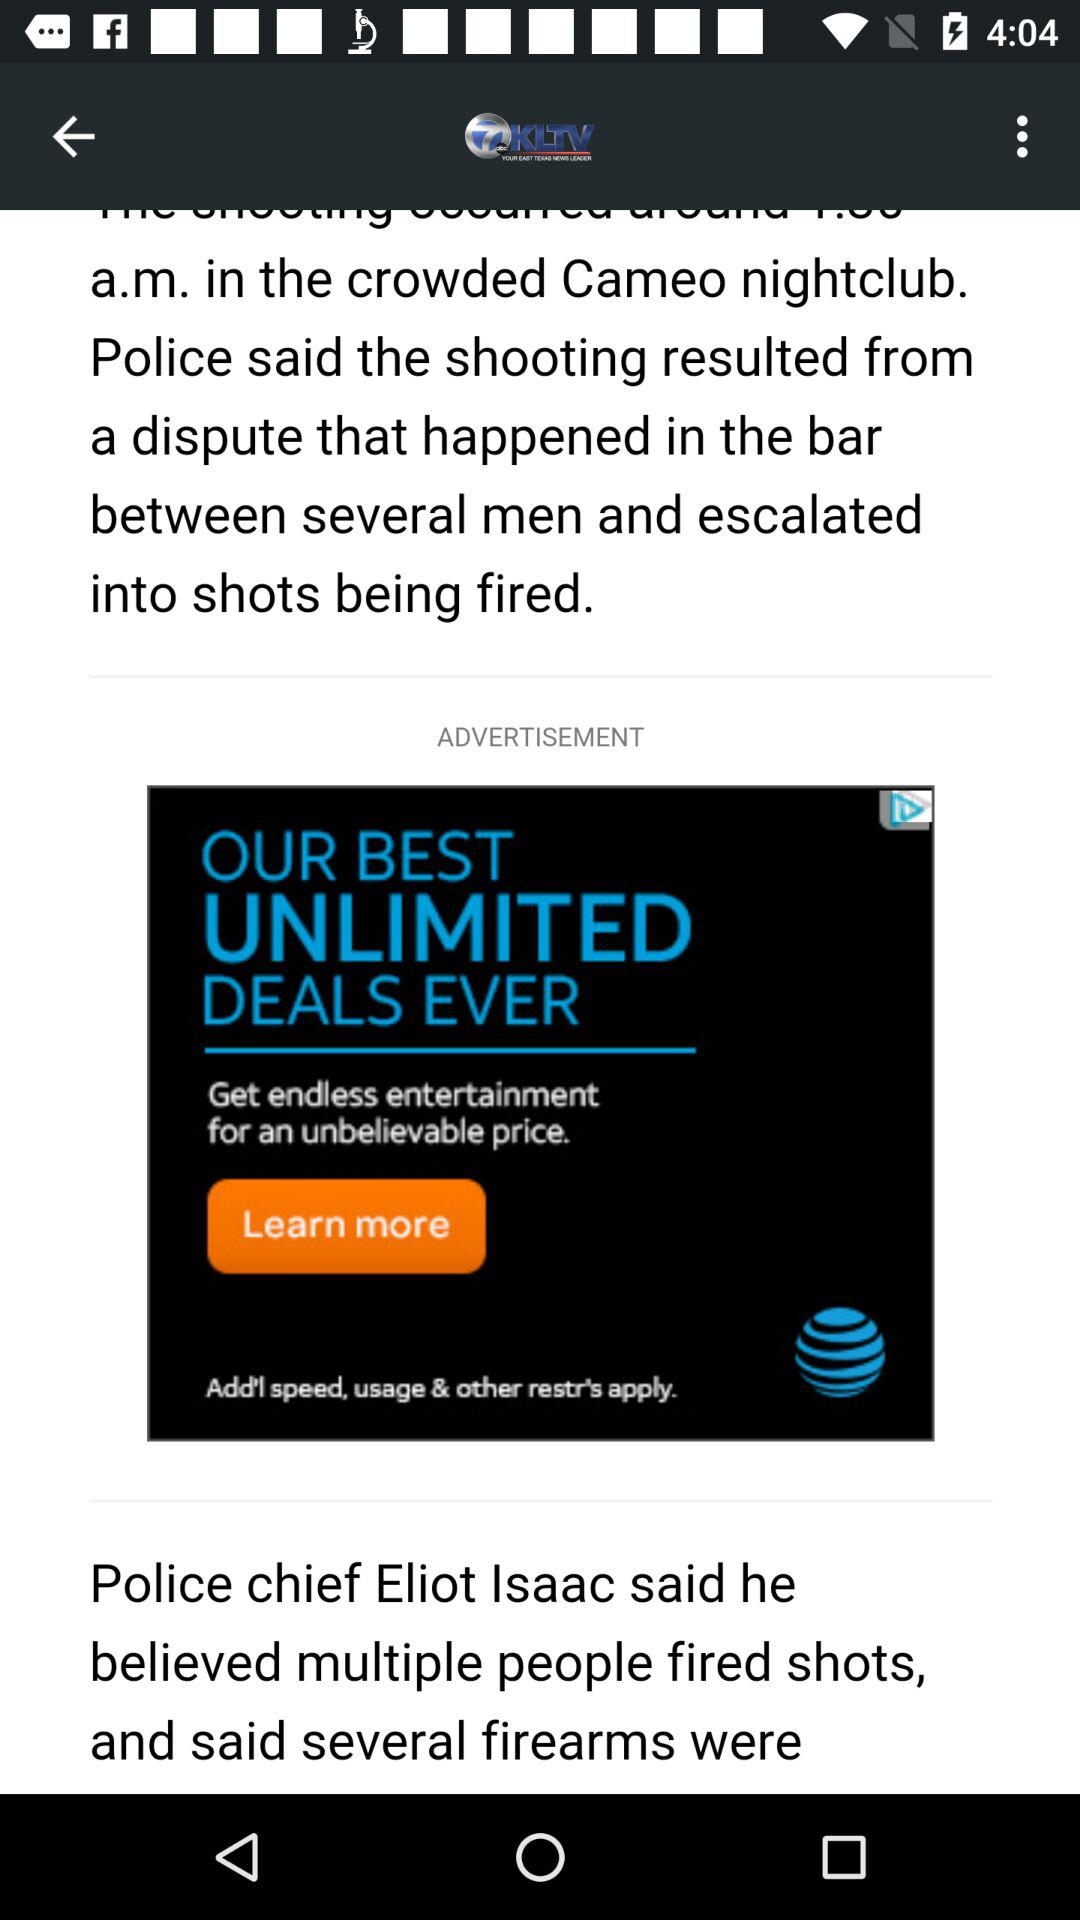What is the application Name? The name of the application is "KLTV". 